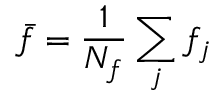<formula> <loc_0><loc_0><loc_500><loc_500>\bar { f } = \frac { 1 } { N _ { f } } \sum _ { j } f _ { j }</formula> 